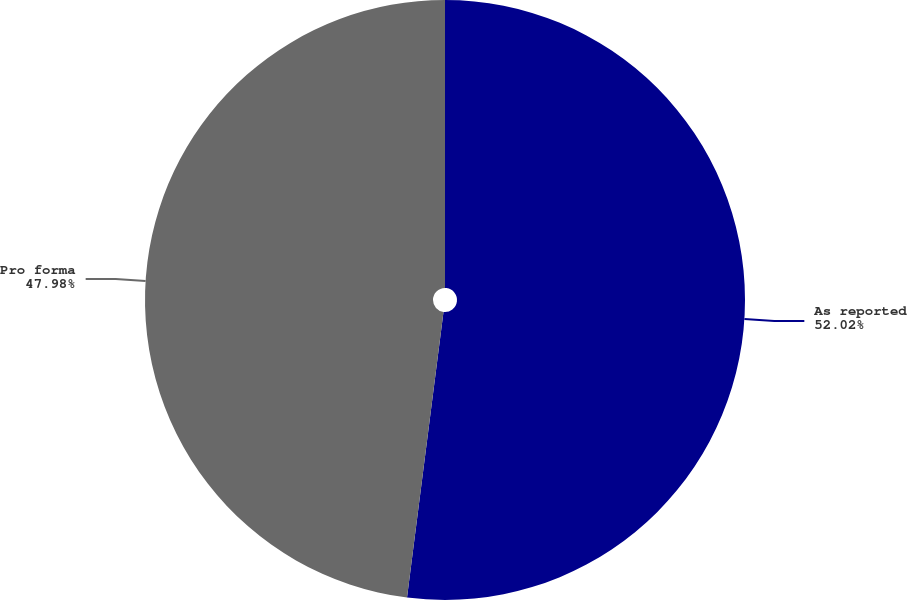Convert chart. <chart><loc_0><loc_0><loc_500><loc_500><pie_chart><fcel>As reported<fcel>Pro forma<nl><fcel>52.02%<fcel>47.98%<nl></chart> 